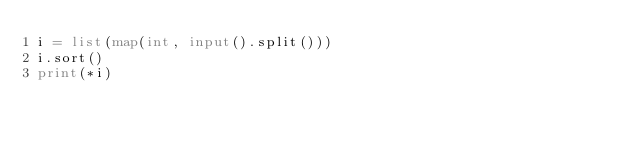<code> <loc_0><loc_0><loc_500><loc_500><_Python_>i = list(map(int, input().split()))
i.sort()
print(*i)
</code> 